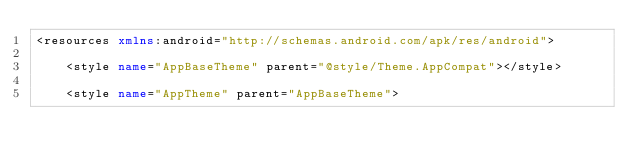<code> <loc_0><loc_0><loc_500><loc_500><_XML_><resources xmlns:android="http://schemas.android.com/apk/res/android">

    <style name="AppBaseTheme" parent="@style/Theme.AppCompat"></style>

    <style name="AppTheme" parent="AppBaseTheme"></code> 